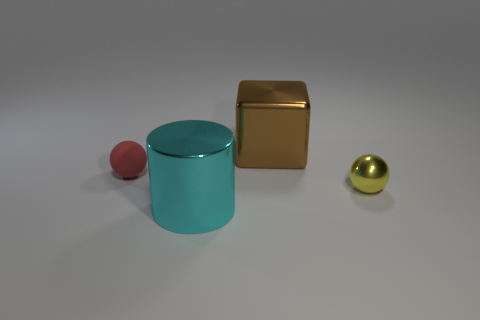Add 1 large cyan metallic cubes. How many objects exist? 5 Subtract all cylinders. How many objects are left? 3 Add 3 red cylinders. How many red cylinders exist? 3 Subtract 0 blue spheres. How many objects are left? 4 Subtract all large cyan metallic cylinders. Subtract all tiny balls. How many objects are left? 1 Add 1 red matte things. How many red matte things are left? 2 